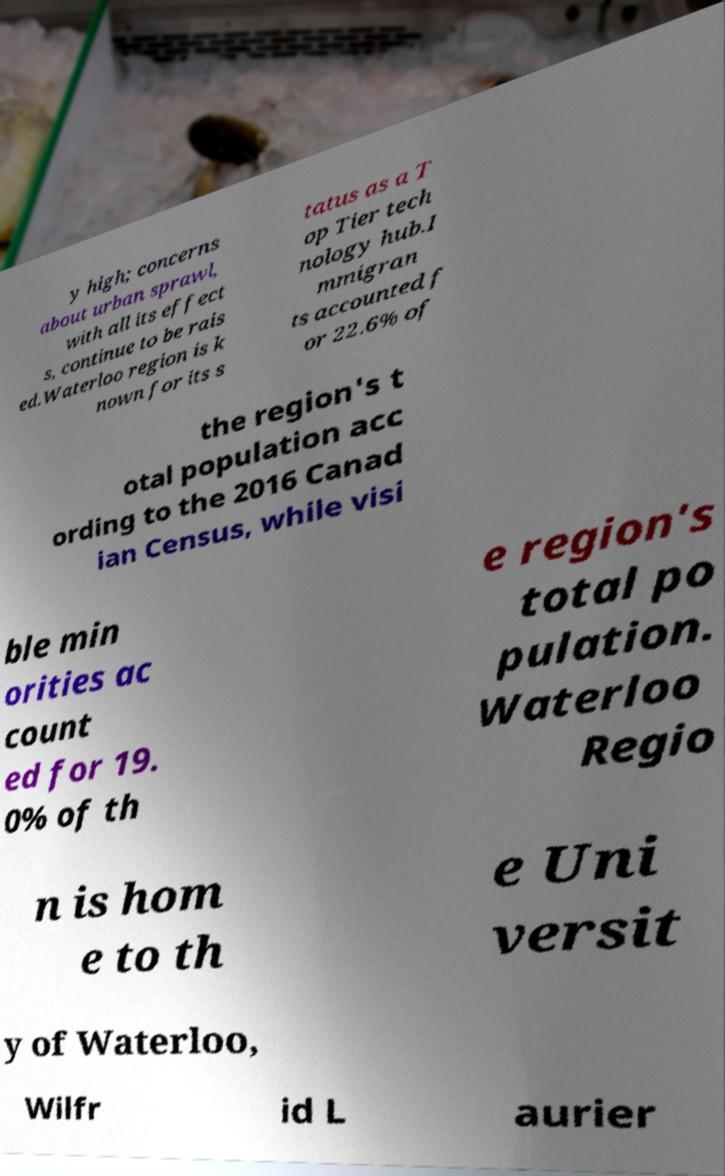Please identify and transcribe the text found in this image. y high; concerns about urban sprawl, with all its effect s, continue to be rais ed.Waterloo region is k nown for its s tatus as a T op Tier tech nology hub.I mmigran ts accounted f or 22.6% of the region's t otal population acc ording to the 2016 Canad ian Census, while visi ble min orities ac count ed for 19. 0% of th e region's total po pulation. Waterloo Regio n is hom e to th e Uni versit y of Waterloo, Wilfr id L aurier 